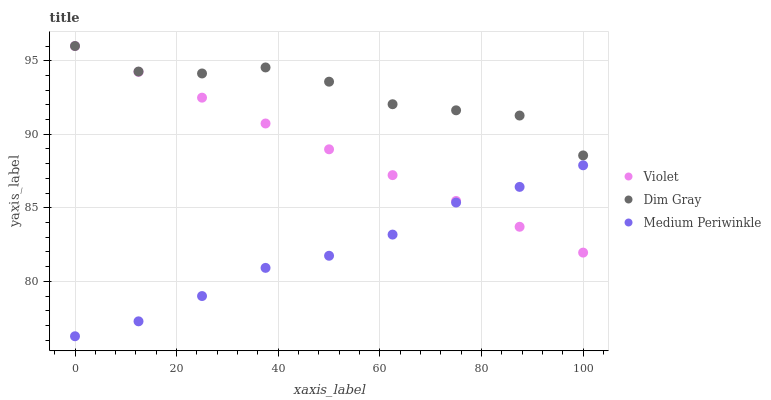Does Medium Periwinkle have the minimum area under the curve?
Answer yes or no. Yes. Does Dim Gray have the maximum area under the curve?
Answer yes or no. Yes. Does Violet have the minimum area under the curve?
Answer yes or no. No. Does Violet have the maximum area under the curve?
Answer yes or no. No. Is Violet the smoothest?
Answer yes or no. Yes. Is Dim Gray the roughest?
Answer yes or no. Yes. Is Medium Periwinkle the smoothest?
Answer yes or no. No. Is Medium Periwinkle the roughest?
Answer yes or no. No. Does Medium Periwinkle have the lowest value?
Answer yes or no. Yes. Does Violet have the lowest value?
Answer yes or no. No. Does Violet have the highest value?
Answer yes or no. Yes. Does Medium Periwinkle have the highest value?
Answer yes or no. No. Is Medium Periwinkle less than Dim Gray?
Answer yes or no. Yes. Is Dim Gray greater than Medium Periwinkle?
Answer yes or no. Yes. Does Violet intersect Medium Periwinkle?
Answer yes or no. Yes. Is Violet less than Medium Periwinkle?
Answer yes or no. No. Is Violet greater than Medium Periwinkle?
Answer yes or no. No. Does Medium Periwinkle intersect Dim Gray?
Answer yes or no. No. 